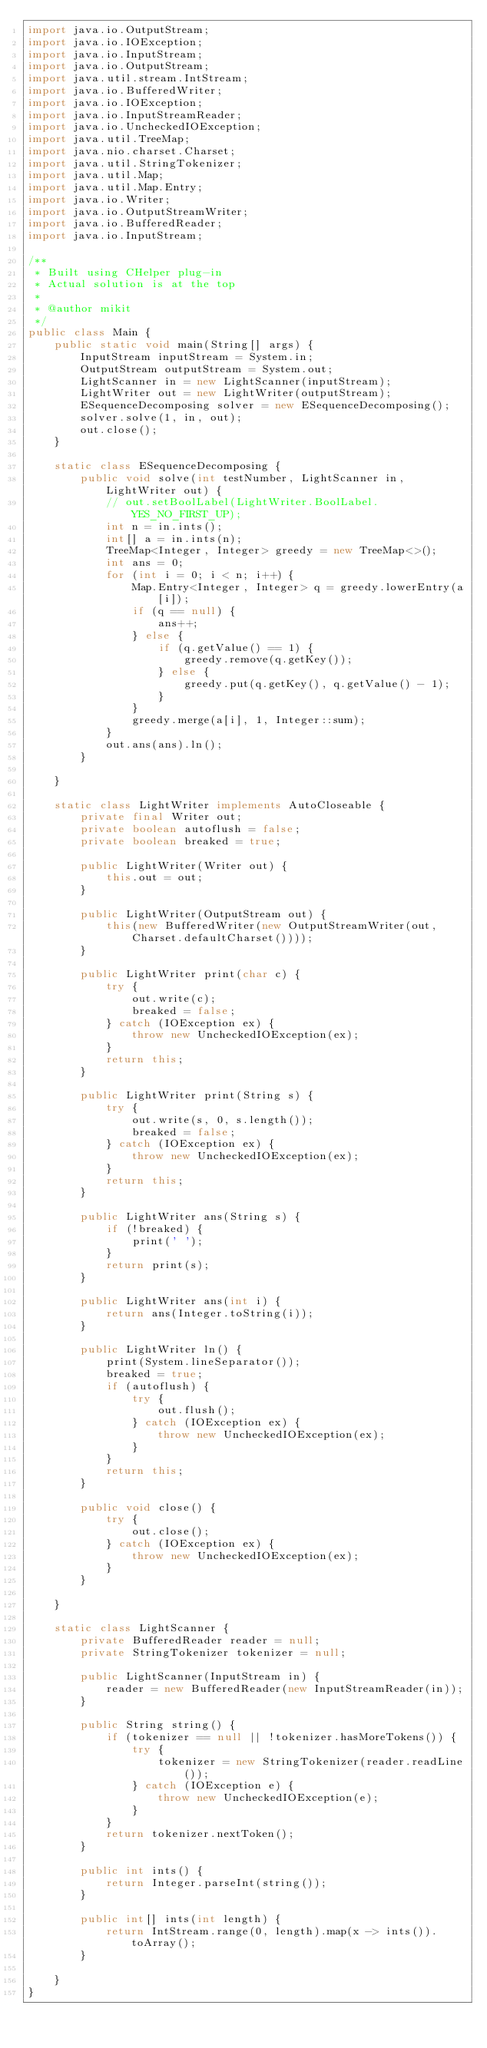<code> <loc_0><loc_0><loc_500><loc_500><_Java_>import java.io.OutputStream;
import java.io.IOException;
import java.io.InputStream;
import java.io.OutputStream;
import java.util.stream.IntStream;
import java.io.BufferedWriter;
import java.io.IOException;
import java.io.InputStreamReader;
import java.io.UncheckedIOException;
import java.util.TreeMap;
import java.nio.charset.Charset;
import java.util.StringTokenizer;
import java.util.Map;
import java.util.Map.Entry;
import java.io.Writer;
import java.io.OutputStreamWriter;
import java.io.BufferedReader;
import java.io.InputStream;

/**
 * Built using CHelper plug-in
 * Actual solution is at the top
 *
 * @author mikit
 */
public class Main {
    public static void main(String[] args) {
        InputStream inputStream = System.in;
        OutputStream outputStream = System.out;
        LightScanner in = new LightScanner(inputStream);
        LightWriter out = new LightWriter(outputStream);
        ESequenceDecomposing solver = new ESequenceDecomposing();
        solver.solve(1, in, out);
        out.close();
    }

    static class ESequenceDecomposing {
        public void solve(int testNumber, LightScanner in, LightWriter out) {
            // out.setBoolLabel(LightWriter.BoolLabel.YES_NO_FIRST_UP);
            int n = in.ints();
            int[] a = in.ints(n);
            TreeMap<Integer, Integer> greedy = new TreeMap<>();
            int ans = 0;
            for (int i = 0; i < n; i++) {
                Map.Entry<Integer, Integer> q = greedy.lowerEntry(a[i]);
                if (q == null) {
                    ans++;
                } else {
                    if (q.getValue() == 1) {
                        greedy.remove(q.getKey());
                    } else {
                        greedy.put(q.getKey(), q.getValue() - 1);
                    }
                }
                greedy.merge(a[i], 1, Integer::sum);
            }
            out.ans(ans).ln();
        }

    }

    static class LightWriter implements AutoCloseable {
        private final Writer out;
        private boolean autoflush = false;
        private boolean breaked = true;

        public LightWriter(Writer out) {
            this.out = out;
        }

        public LightWriter(OutputStream out) {
            this(new BufferedWriter(new OutputStreamWriter(out, Charset.defaultCharset())));
        }

        public LightWriter print(char c) {
            try {
                out.write(c);
                breaked = false;
            } catch (IOException ex) {
                throw new UncheckedIOException(ex);
            }
            return this;
        }

        public LightWriter print(String s) {
            try {
                out.write(s, 0, s.length());
                breaked = false;
            } catch (IOException ex) {
                throw new UncheckedIOException(ex);
            }
            return this;
        }

        public LightWriter ans(String s) {
            if (!breaked) {
                print(' ');
            }
            return print(s);
        }

        public LightWriter ans(int i) {
            return ans(Integer.toString(i));
        }

        public LightWriter ln() {
            print(System.lineSeparator());
            breaked = true;
            if (autoflush) {
                try {
                    out.flush();
                } catch (IOException ex) {
                    throw new UncheckedIOException(ex);
                }
            }
            return this;
        }

        public void close() {
            try {
                out.close();
            } catch (IOException ex) {
                throw new UncheckedIOException(ex);
            }
        }

    }

    static class LightScanner {
        private BufferedReader reader = null;
        private StringTokenizer tokenizer = null;

        public LightScanner(InputStream in) {
            reader = new BufferedReader(new InputStreamReader(in));
        }

        public String string() {
            if (tokenizer == null || !tokenizer.hasMoreTokens()) {
                try {
                    tokenizer = new StringTokenizer(reader.readLine());
                } catch (IOException e) {
                    throw new UncheckedIOException(e);
                }
            }
            return tokenizer.nextToken();
        }

        public int ints() {
            return Integer.parseInt(string());
        }

        public int[] ints(int length) {
            return IntStream.range(0, length).map(x -> ints()).toArray();
        }

    }
}

</code> 